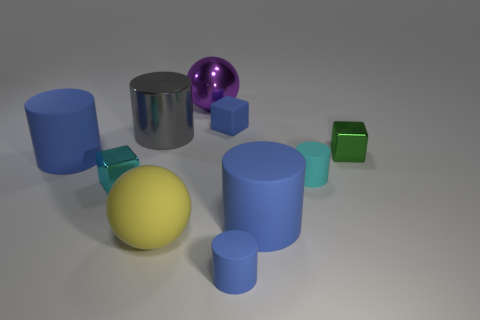What number of big cylinders are the same color as the tiny matte cube?
Ensure brevity in your answer.  2. What color is the other metal object that is the same size as the green thing?
Ensure brevity in your answer.  Cyan. What number of matte things are either small yellow blocks or large things?
Your answer should be very brief. 3. What color is the big cylinder that is made of the same material as the cyan cube?
Make the answer very short. Gray. What is the material of the cyan object that is on the left side of the cyan thing right of the yellow object?
Keep it short and to the point. Metal. How many things are either objects that are in front of the small blue block or small rubber things behind the big gray thing?
Your answer should be very brief. 9. There is a block to the left of the small blue object behind the large cylinder to the right of the purple object; what is its size?
Ensure brevity in your answer.  Small. Are there the same number of cyan cylinders behind the small green metal object and large rubber cylinders?
Offer a very short reply. No. Do the green object and the large blue matte object on the left side of the big gray metallic cylinder have the same shape?
Make the answer very short. No. What is the size of the cyan object that is the same shape as the big gray shiny object?
Your response must be concise. Small. 